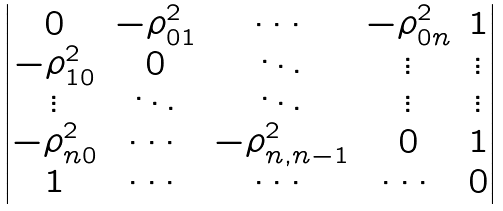Convert formula to latex. <formula><loc_0><loc_0><loc_500><loc_500>\begin{vmatrix} 0 & - \rho _ { 0 1 } ^ { 2 } & \cdots & - \rho _ { 0 n } ^ { 2 } & 1 \\ - \rho _ { 1 0 } ^ { 2 } & 0 & \ddots & \vdots & \vdots \\ \vdots & \ddots & \ddots & \vdots & \vdots \\ - \rho _ { n 0 } ^ { 2 } & \cdots & - \rho _ { n , n - 1 } ^ { 2 } & 0 & 1 \\ 1 & \cdots & \cdots & \cdots & 0 \end{vmatrix}</formula> 